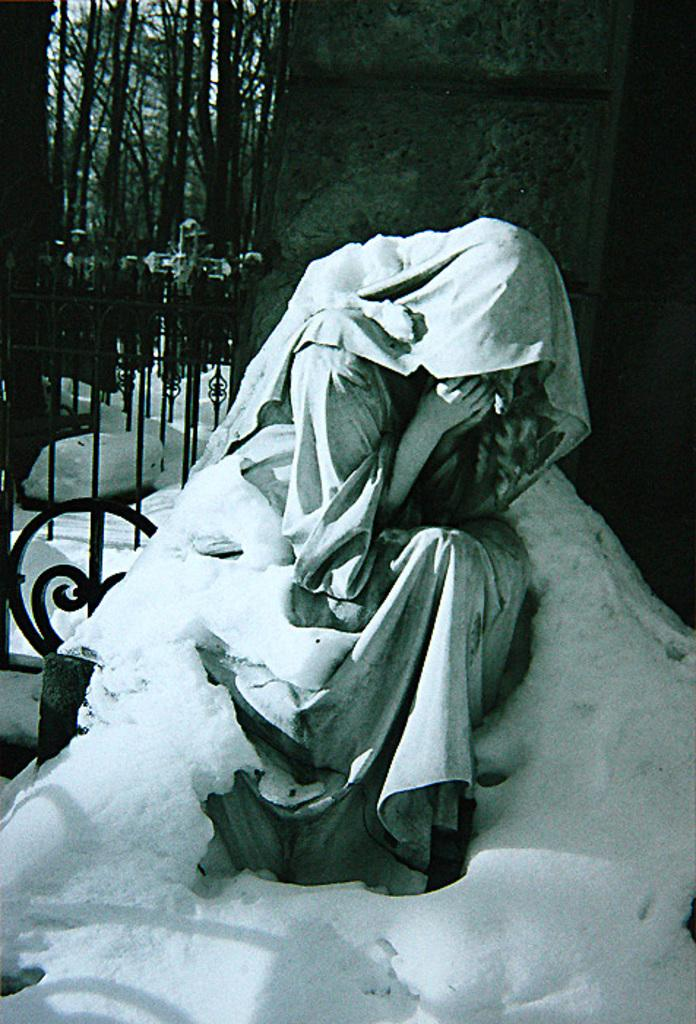What is the main subject of the image? There is a sculpture of a person in the image. How is the sculpture affected by the environment? The sculpture is partially covered with snow. What type of barrier can be seen in the image? There is a fence in the image. What type of vegetation is present in the image? There are trees in the image. Can you see any birds perched on the sculpture in the image? There are no birds visible in the image, as the focus is on the sculpture and its surroundings. 